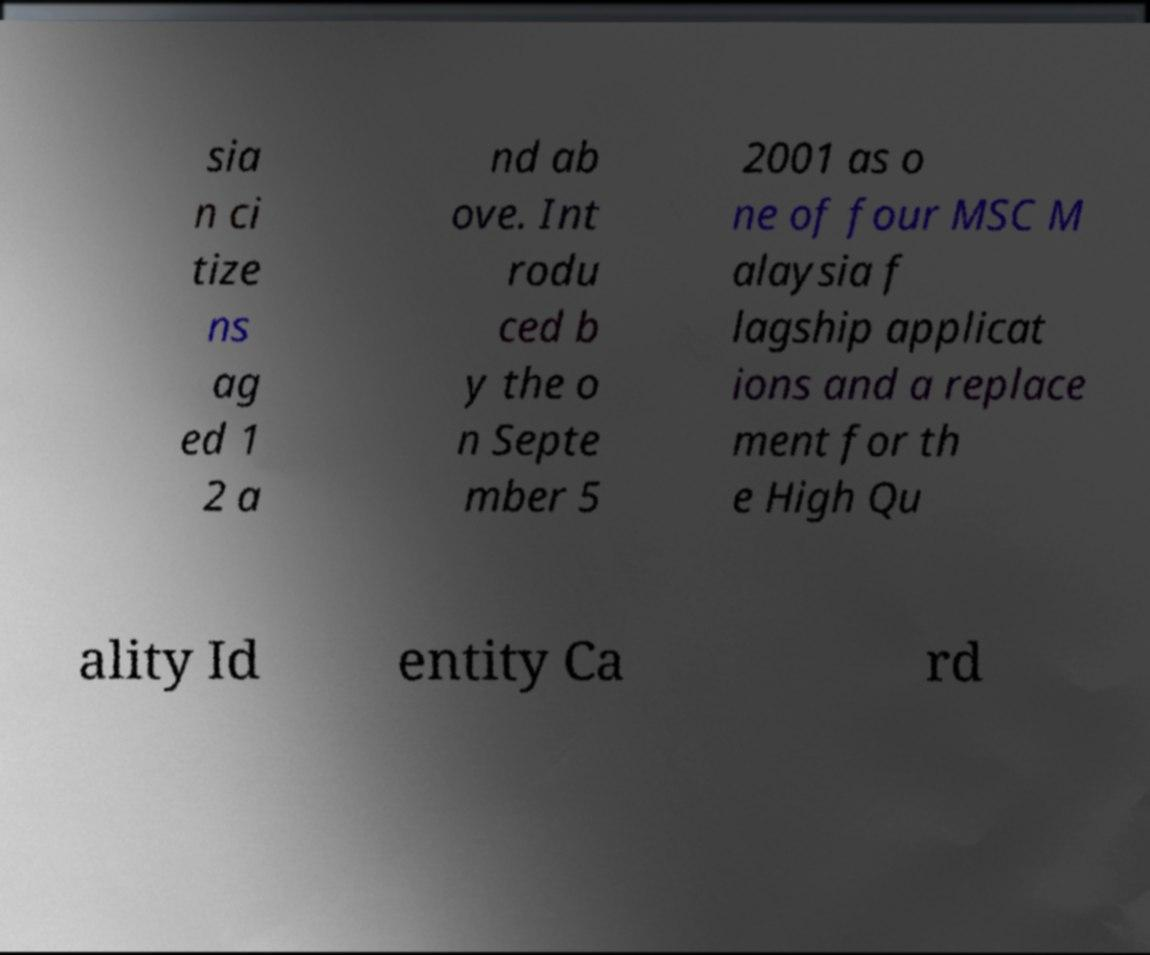What messages or text are displayed in this image? I need them in a readable, typed format. sia n ci tize ns ag ed 1 2 a nd ab ove. Int rodu ced b y the o n Septe mber 5 2001 as o ne of four MSC M alaysia f lagship applicat ions and a replace ment for th e High Qu ality Id entity Ca rd 